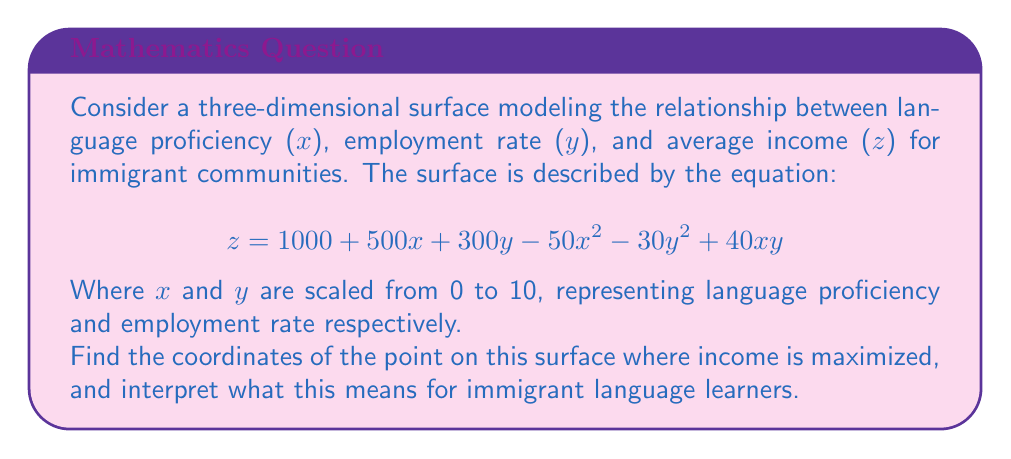Solve this math problem. To find the maximum point on this surface, we need to follow these steps:

1) First, we need to find the partial derivatives of z with respect to x and y:

   $\frac{\partial z}{\partial x} = 500 - 100x + 40y$
   $\frac{\partial z}{\partial y} = 300 - 60y + 40x$

2) At the maximum point, both of these partial derivatives will equal zero. So we set up the system of equations:

   $500 - 100x + 40y = 0$
   $300 - 60y + 40x = 0$

3) Solving this system of equations:
   From the first equation: $y = \frac{100x - 500}{40} = 2.5x - 12.5$
   
   Substituting this into the second equation:
   $300 - 60(2.5x - 12.5) + 40x = 0$
   $300 - 150x + 750 + 40x = 0$
   $1050 - 110x = 0$
   $x = \frac{1050}{110} = 9.545$

   Substituting this x value back into the equation for y:
   $y = 2.5(9.545) - 12.5 = 11.36$

4) However, our domain for x and y is [0, 10]. The y-value is outside this range, so the maximum must occur at the boundary.

5) Given that y is capped at 10, we can solve for x when y = 10:
   $500 - 100x + 40(10) = 0$
   $900 - 100x = 0$
   $x = 9$

6) To find the maximum z value, we substitute x = 9 and y = 10 into our original equation:
   $z = 1000 + 500(9) + 300(10) - 50(9^2) - 30(10^2) + 40(9)(10)$
   $= 1000 + 4500 + 3000 - 4050 - 3000 + 3600$
   $= 5050$

Therefore, the maximum point occurs at (9, 10, 5050).

Interpretation: This means that for immigrant language learners, income is maximized when language proficiency is very high (9 out of 10) and the employment rate is at its maximum (10 out of 10). This underscores the importance of both language skills and employment opportunities for maximizing income in immigrant communities.
Answer: (9, 10, 5050) 